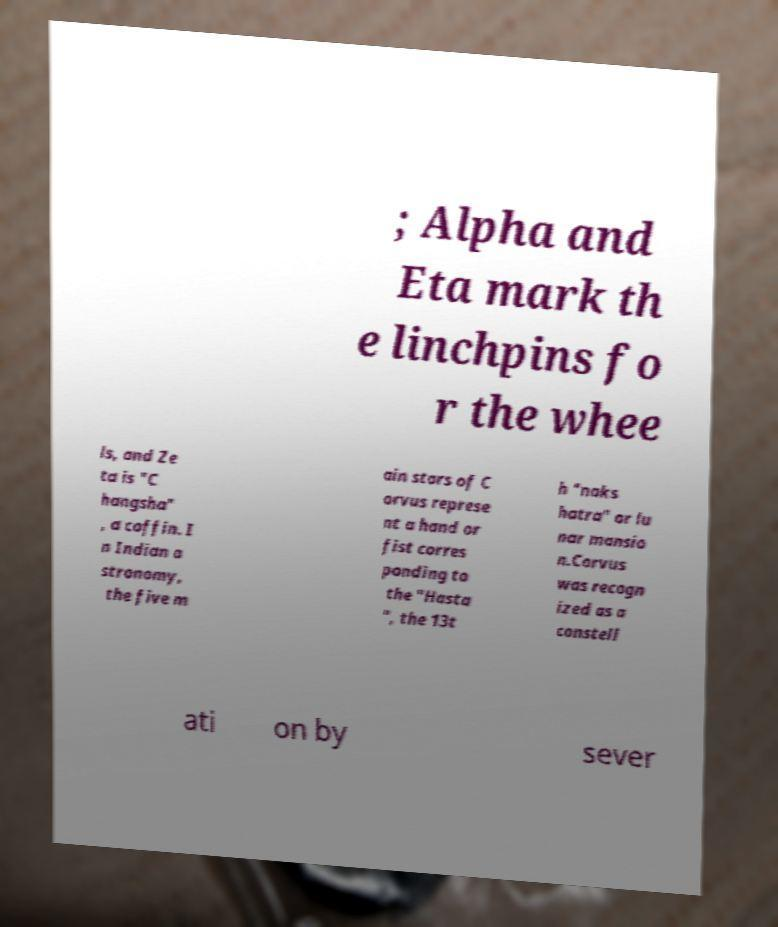There's text embedded in this image that I need extracted. Can you transcribe it verbatim? ; Alpha and Eta mark th e linchpins fo r the whee ls, and Ze ta is "C hangsha" , a coffin. I n Indian a stronomy, the five m ain stars of C orvus represe nt a hand or fist corres ponding to the "Hasta ", the 13t h "naks hatra" or lu nar mansio n.Corvus was recogn ized as a constell ati on by sever 